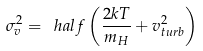<formula> <loc_0><loc_0><loc_500><loc_500>\sigma ^ { 2 } _ { v } = \ h a l f \left ( \frac { 2 k T } { m _ { H } } + v ^ { 2 } _ { t u r b } \right )</formula> 